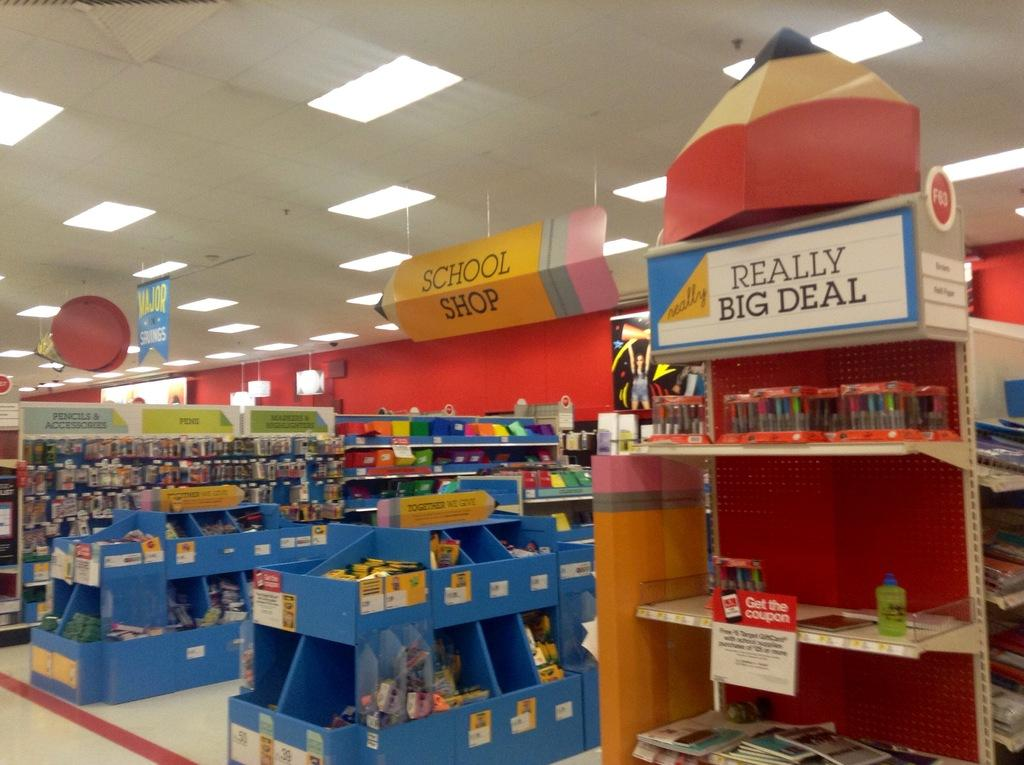<image>
Relay a brief, clear account of the picture shown. yellow sign shaped like a pencil showing where the school shop is and an isle advertising a really big deal 